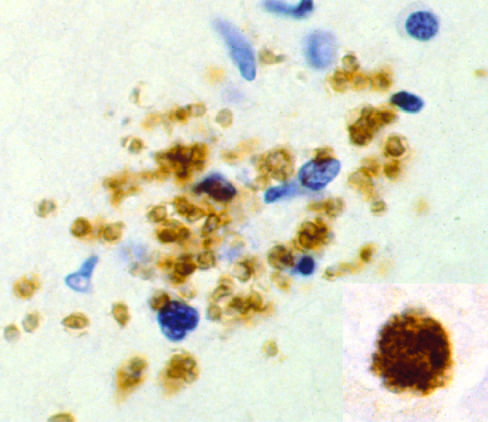re inset, bradyzoites present as a pseudocyst, again highlighted by immunohistochemical staining?
Answer the question using a single word or phrase. Yes 